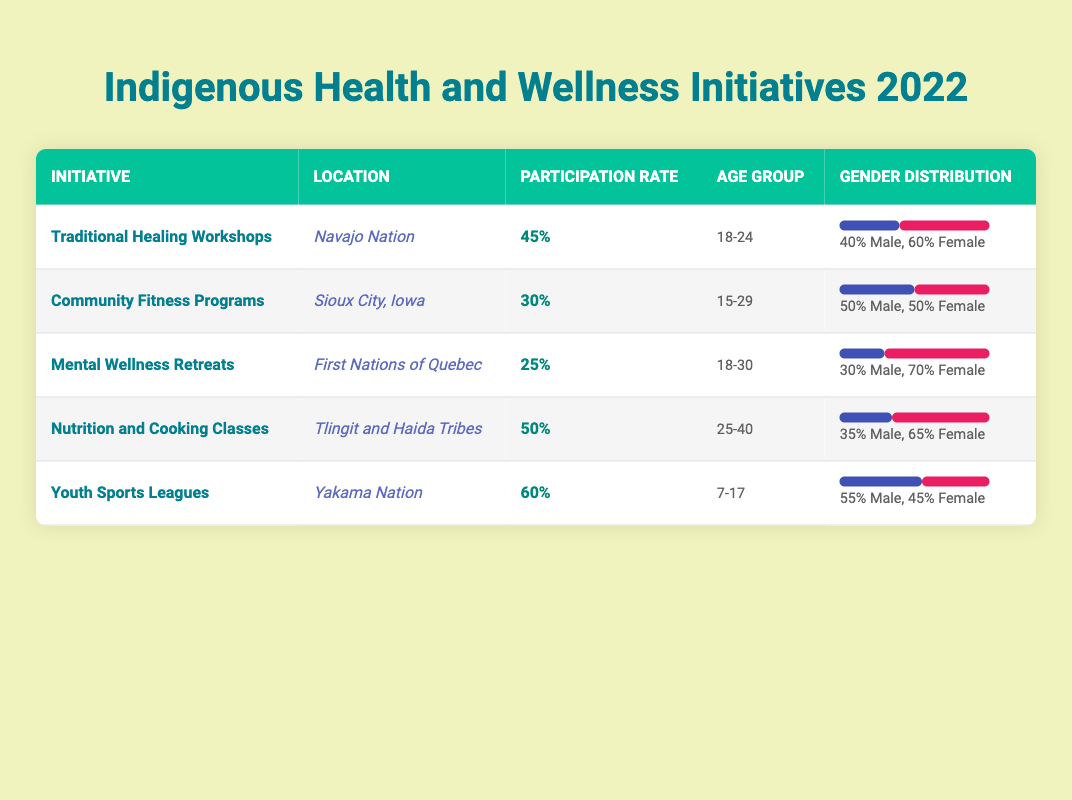What is the participation rate for Traditional Healing Workshops? The table lists the participation rate for Traditional Healing Workshops as 45%.
Answer: 45% Which initiative had the highest participation rate? By comparing the participation rates in the table, Youth Sports Leagues have the highest participation rate at 60%.
Answer: 60% Which age group participated in Mental Wellness Retreats? The demographics for Mental Wellness Retreats show that the age group is 18-30.
Answer: 18-30 What is the gender distribution for Nutrition and Cooking Classes? The table indicates that the gender distribution for Nutrition and Cooking Classes is 35% male and 65% female.
Answer: 35% Male, 65% Female Is the participation rate for Community Fitness Programs greater than or equal to 25%? The participation rate for Community Fitness Programs is 30%, which is greater than 25%.
Answer: Yes What is the average participation rate for all the initiatives listed? The participation rates are 45%, 30%, 25%, 50%, and 60%. First, sum these values: 45 + 30 + 25 + 50 + 60 = 210. Then, divide by the number of initiatives (5): 210 / 5 = 42.
Answer: 42 Did any initiative have a male participation rate greater than 50%? The gender distribution for Youth Sports Leagues shows a male participation rate of 55%, which is greater than 50%.
Answer: Yes What initiative had the lowest female participation rate? The initiative with the lowest female participation rate is Mental Wellness Retreats, with 70% female participation.
Answer: Mental Wellness Retreats How many initiatives focused on participants aged 25 and older? The initiatives that focused on participants aged 25 and older are Nutrition and Cooking Classes and Traditional Healing Workshops. This counts to 2 initiatives.
Answer: 2 